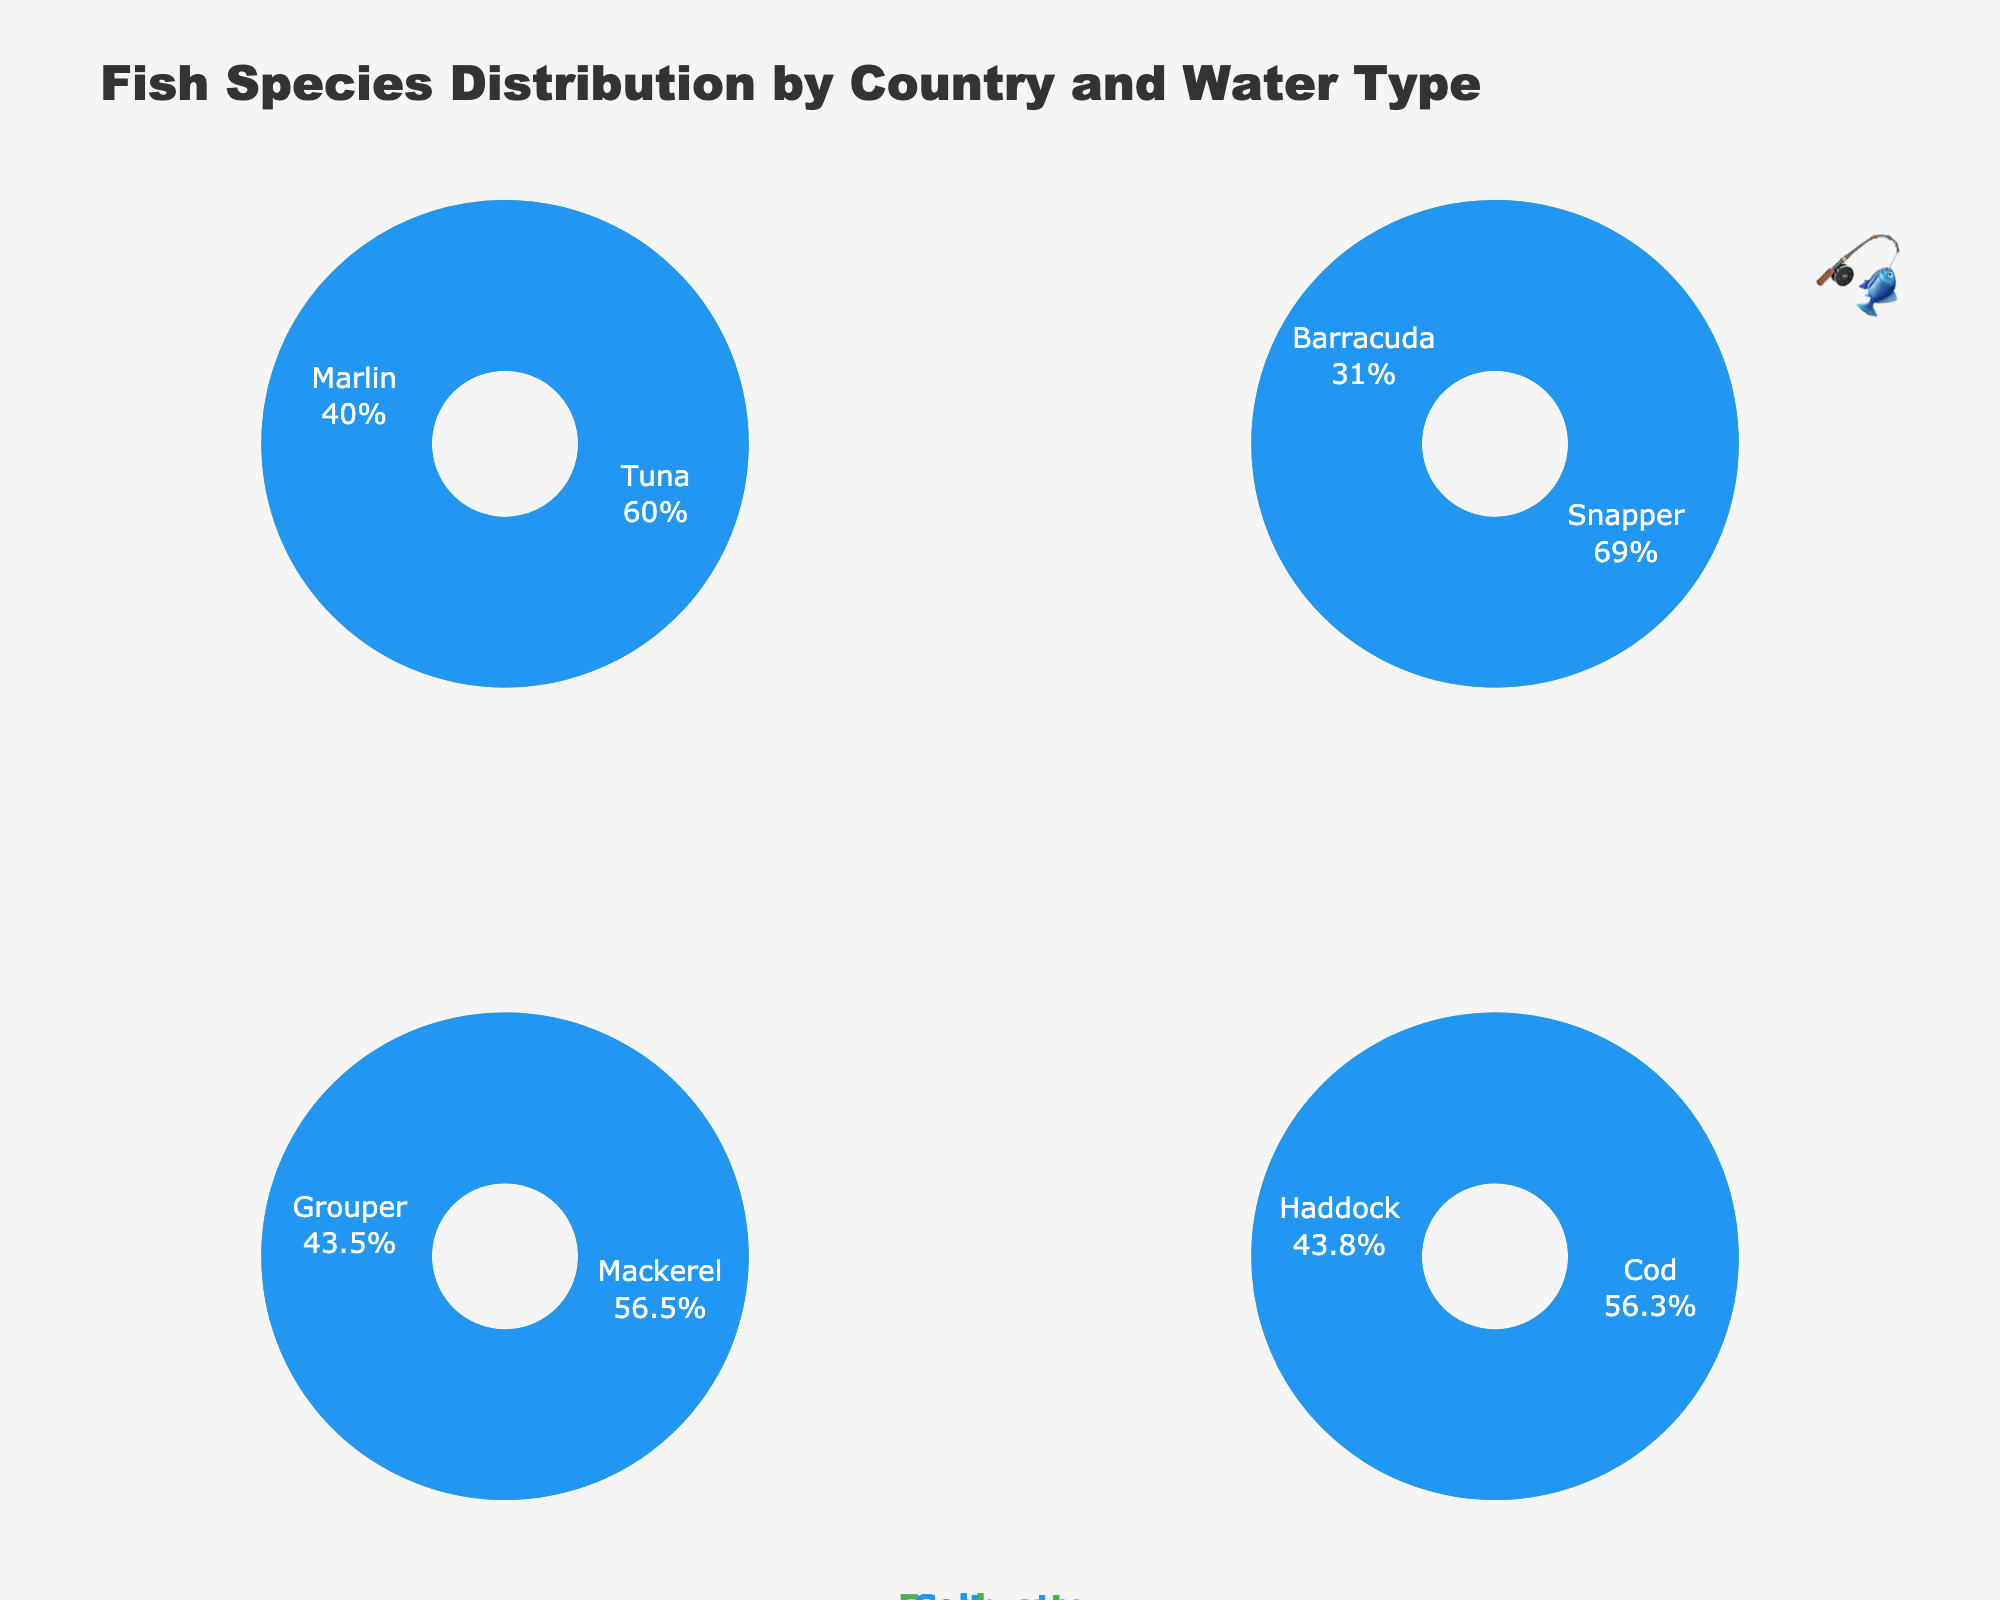Which country has the highest count of freshwater fish species combined? For each country, sum the counts of freshwater fish species. USA: 150 (Trout) + 200 (Bass) = 350, Australia: 170 (Catfish) + 220 (Perch) = 390, Brazil: 50 (Pirahna) + 140 (Pacu) = 190, Norway: 40 (Pike) + 60 (Salmon) = 100. Therefore, Australia has the highest count.
Answer: Australia Which saltwater fish species in Brazil has a higher count, Grouper or Mackerel? In the Brazil subplot for saltwater fish, compare the counts for Grouper and Mackerel. Grouper has 100 and Mackerel has 130. Thus, Mackerel has a higher count.
Answer: Mackerel What is the total number of fish species counts in the saltwater category for Norway? Sum up the counts of the saltwater fish species in Norway. Cod has 180 and Haddock has 140. The total is 180 + 140 = 320.
Answer: 320 Which country has more saltwater fish species, USA or Norway? Compare the number of different saltwater fish species between the USA and Norway. USA has Tuna and Marlin (2 species), while Norway has Cod and Haddock (2 species). Both countries have the same number of saltwater fish species.
Answer: Same What's the percentage of Perch among all freshwater fish in Australia? First, find the total count of freshwater fish in Australia, which is 170 (Catfish) + 220 (Perch) = 390. Then, calculate the percentage of Perch: (220 / 390) * 100 ≈ 56.41%.
Answer: 56.41% In which country is Snapper a prominent saltwater fish species? Look for the subplot and water type where Snapper appears. Snapper is a saltwater fish species in Australia.
Answer: Australia Compare the counts of Trout and Bass in the USA. Which one is higher and by how much? In the USA subplot for freshwater fish, compare the counts of Trout and Bass. Trout has 150 and Bass has 200. Bass is higher by 200 - 150 = 50.
Answer: Bass by 50 